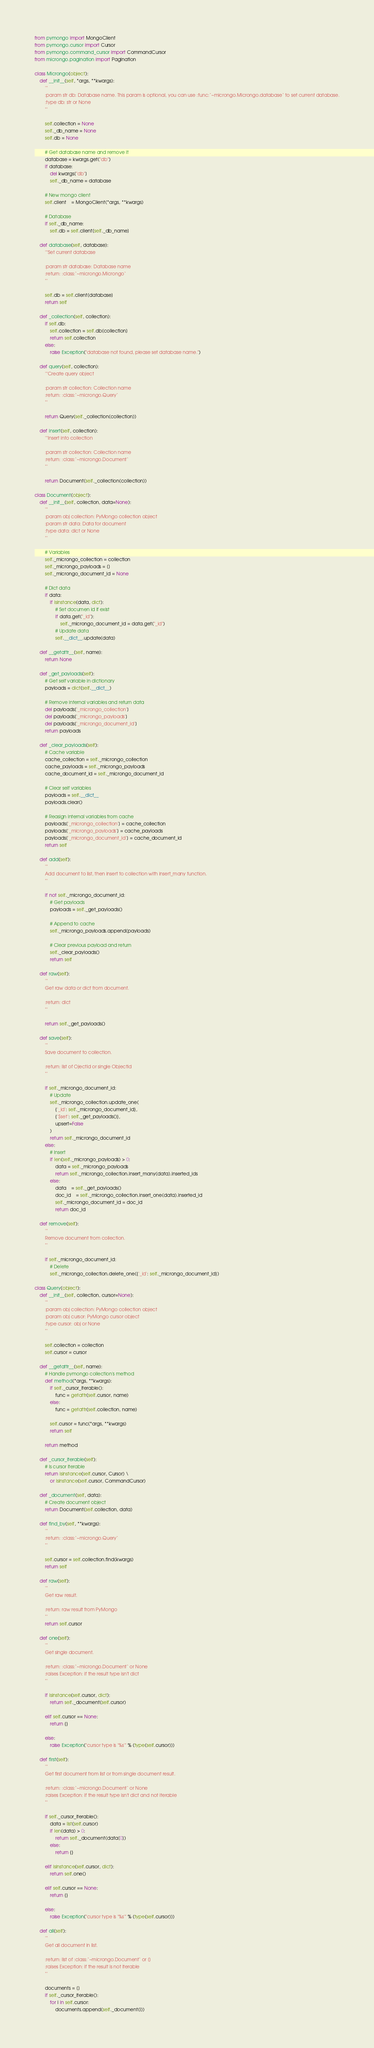<code> <loc_0><loc_0><loc_500><loc_500><_Python_>from pymongo import MongoClient
from pymongo.cursor import Cursor
from pymongo.command_cursor import CommandCursor
from microngo.pagination import Pagination

class Microngo(object):
	def __init__(self, *args, **kwargs):
		'''
		:param str db: Database name. This param is optional, you can use :func:`~microngo.Microngo.database` to set current database.
		:type db: str or None
		'''

		self.collection = None
		self._db_name = None
		self.db = None

		# Get database name and remove it
		database = kwargs.get("db")
		if database:
			del kwargs["db"]
			self._db_name = database

		# New mongo client
		self.client	= MongoClient(*args, **kwargs)

		# Database
		if self._db_name:
			self.db = self.client[self._db_name]

	def database(self, database):
		'''Set current database

		:param str database: Database name
		:return: :class:`~microngo.Microngo`
		'''

		self.db = self.client[database]
		return self

	def _collection(self, collection):
		if self.db:
			self.collection = self.db[collection]
			return self.collection 
		else:
			raise Exception("database not found, please set database name.")

	def query(self, collection):
		'''Create query object

		:param str collection: Collection name
		:return: :class:`~microngo.Query`
		'''

		return Query(self._collection(collection))
	
	def insert(self, collection):
		'''Insert into collection

		:param str collection: Collection name
		:return: :class:`~microngo.Document`
		'''

		return Document(self._collection(collection))

class Document(object):
	def __init__(self, collection, data=None):
		'''
		:param obj collection: PyMongo collection object
		:param str data: Data for document
		:type data: dict or None
		'''

		# Variables
		self._microngo_collection = collection
		self._microngo_payloads = []
		self._microngo_document_id = None

		# Dict data
		if data:
			if isinstance(data, dict):
				# Set documen id if exist
				if data.get("_id"):
					self._microngo_document_id = data.get("_id")
				# Update data
				self.__dict__.update(data)

	def __getattr__(self, name):
		return None

	def _get_payloads(self):
		# Get self variable in dictionary
		payloads = dict(self.__dict__)

		# Remove internal variables and return data
		del payloads['_microngo_collection']
		del payloads['_microngo_payloads']
		del payloads['_microngo_document_id']
		return payloads

	def _clear_payloads(self):
		# Cache variable
		cache_collection = self._microngo_collection
		cache_payloads = self._microngo_payloads
		cache_document_id = self._microngo_document_id

		# Clear self variables
		payloads = self.__dict__
		payloads.clear()

		# Reasign internal variables from cache
		payloads['_microngo_collection'] = cache_collection
		payloads['_microngo_payloads'] = cache_payloads
		payloads['_microngo_document_id'] = cache_document_id
		return self

	def add(self):
		'''
		Add document to list, then insert to collection with insert_many function.
		'''

		if not self._microngo_document_id:
			# Get payloads
			payloads = self._get_payloads()

			# Append to cache
			self._microngo_payloads.append(payloads)

			# Clear previous payload and return
			self._clear_payloads()
			return self

	def raw(self):
		'''
		Get raw data or dict from document.

		:return: dict
		'''

		return self._get_payloads()

	def save(self):
		'''
		Save document to collection.

		:return: list of OjectId or single ObjectId
		'''

		if self._microngo_document_id:
			# Update
			self._microngo_collection.update_one(
				{'_id': self._microngo_document_id},
				{'$set': self._get_payloads()},
				upsert=False
			)
			return self._microngo_document_id
		else:
			# Insert
			if len(self._microngo_payloads) > 0:
				data = self._microngo_payloads
				return self._microngo_collection.insert_many(data).inserted_ids
			else:
				data	= self._get_payloads()
				doc_id	= self._microngo_collection.insert_one(data).inserted_id
				self._microngo_document_id = doc_id
				return doc_id

	def remove(self):
		'''
		Remove document from collection.
		'''

		if self._microngo_document_id:
			# Delete
			self._microngo_collection.delete_one({'_id': self._microngo_document_id})

class Query(object):
	def __init__(self, collection, cursor=None):
		'''
		:param obj collection: PyMongo collection object
		:param obj cursor: PyMongo cursor object
		:type cursor: obj or None
		'''

		self.collection = collection
		self.cursor = cursor

	def __getattr__(self, name):
		# Handle pymongo collection's method
		def method(*args, **kwargs):
			if self._cursor_iterable():
				func = getattr(self.cursor, name)
			else:
				func = getattr(self.collection, name)

			self.cursor = func(*args, **kwargs)
			return self

		return method

	def _cursor_iterable(self):
		# Is cursor iterable
		return isinstance(self.cursor, Cursor) \
			or isinstance(self.cursor, CommandCursor)

	def _document(self, data):
		# Create document object
		return Document(self.collection, data)

	def find_by(self, **kwargs):
		'''
		:return: :class:`~microngo.Query`
		'''

		self.cursor = self.collection.find(kwargs)
		return self

	def raw(self):
		'''
		Get raw result.

		:return: raw result from PyMongo
		'''
		return self.cursor

	def one(self):
		'''
		Get single document.

		:return: :class:`~microngo.Document` or None
		:raises Exception: if the result type isn't dict
		'''

		if isinstance(self.cursor, dict):
			return self._document(self.cursor)

		elif self.cursor == None:
			return {}

		else:
			raise Exception("cursor type is '%s'" % (type(self.cursor)))
	
	def first(self):
		'''
		Get first document from list or from single document result.

		:return: :class:`~microngo.Document` or None
		:raises Exception: if the result type isn't dict and not iterable
		'''

		if self._cursor_iterable():
			data = list(self.cursor)
			if len(data) > 0:
				return self._document(data[0])
			else:
				return {}

		elif isinstance(self.cursor, dict):
			return self.one()

		elif self.cursor == None:
			return {}

		else:
			raise Exception("cursor type is '%s'" % (type(self.cursor)))

	def all(self):
		'''
		Get all document in list.

		:return: list of :class:`~microngo.Document` or []
		:raises Exception: if the result is not iterable
		'''

		documents = []
		if self._cursor_iterable():
			for i in self.cursor:
				documents.append(self._document(i))
</code> 